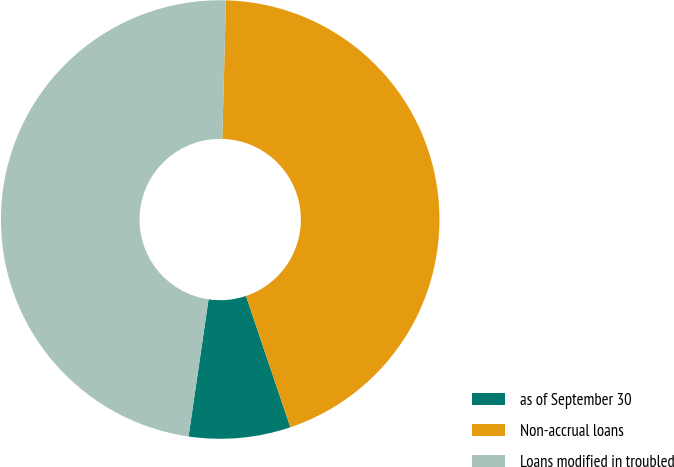<chart> <loc_0><loc_0><loc_500><loc_500><pie_chart><fcel>as of September 30<fcel>Non-accrual loans<fcel>Loans modified in troubled<nl><fcel>7.49%<fcel>44.4%<fcel>48.11%<nl></chart> 